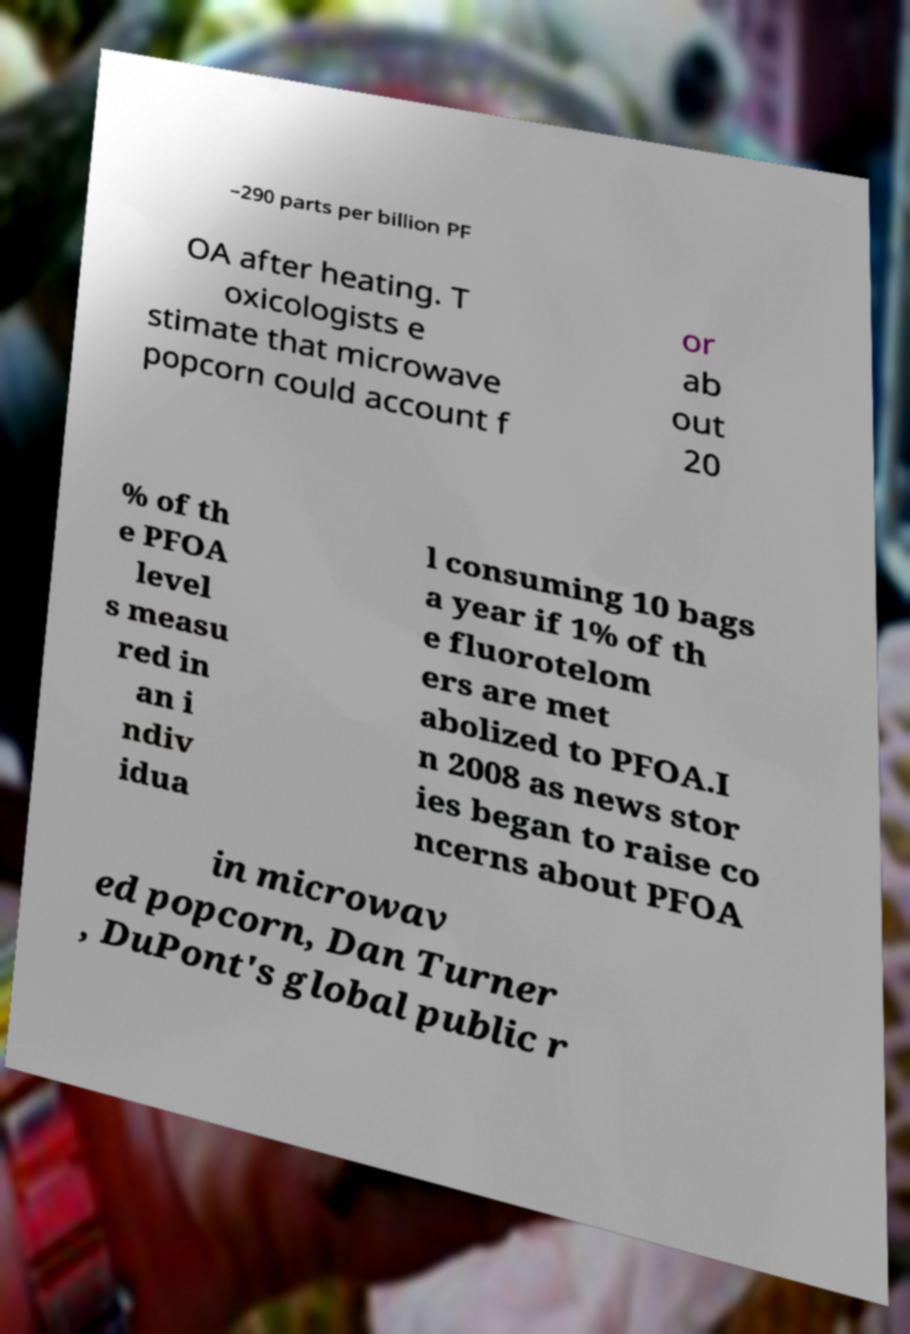Please read and relay the text visible in this image. What does it say? –290 parts per billion PF OA after heating. T oxicologists e stimate that microwave popcorn could account f or ab out 20 % of th e PFOA level s measu red in an i ndiv idua l consuming 10 bags a year if 1% of th e fluorotelom ers are met abolized to PFOA.I n 2008 as news stor ies began to raise co ncerns about PFOA in microwav ed popcorn, Dan Turner , DuPont's global public r 